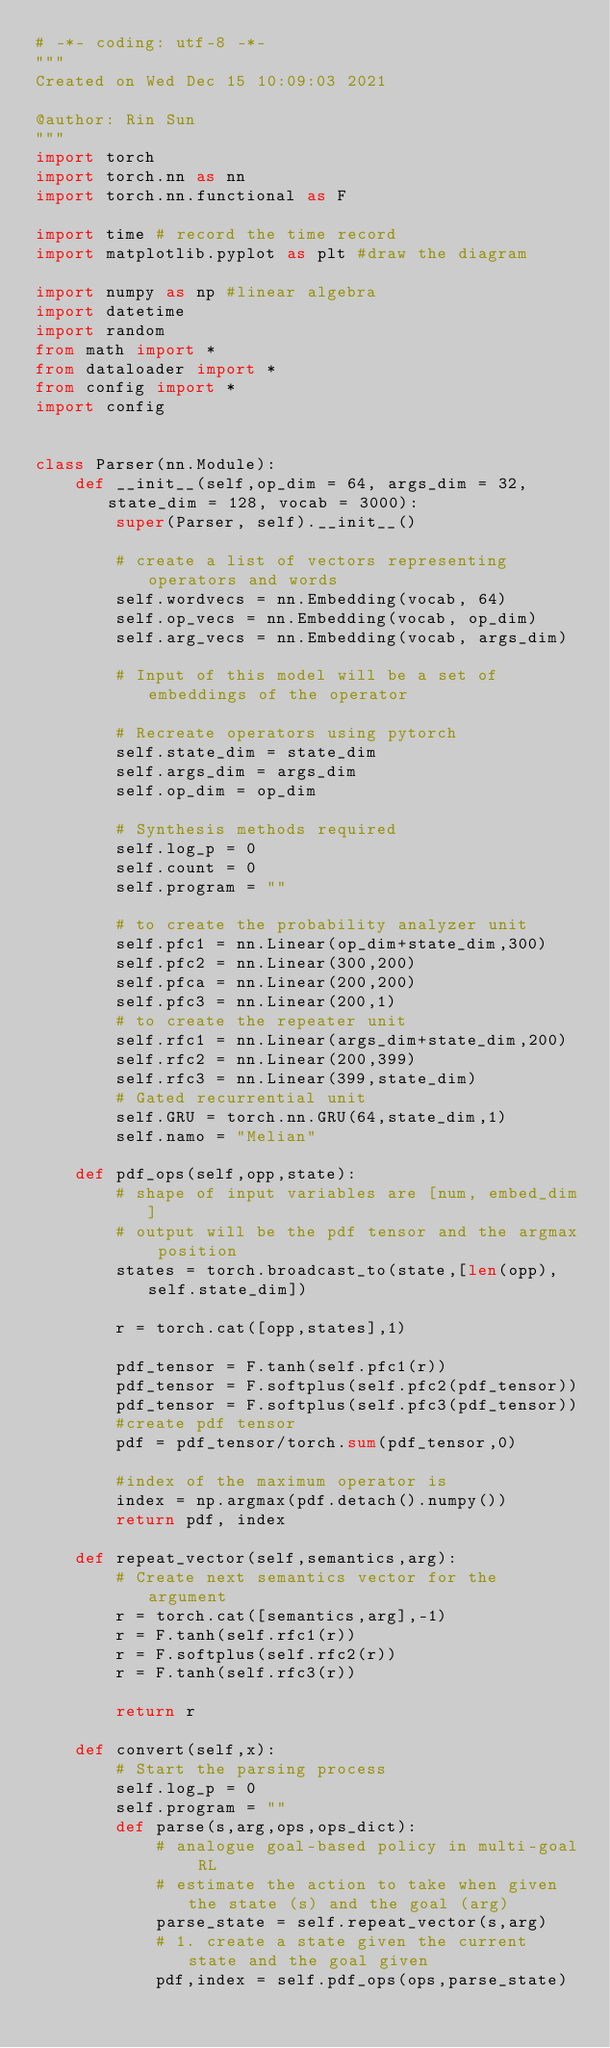Convert code to text. <code><loc_0><loc_0><loc_500><loc_500><_Python_># -*- coding: utf-8 -*-
"""
Created on Wed Dec 15 10:09:03 2021

@author: Rin Sun
"""
import torch
import torch.nn as nn
import torch.nn.functional as F

import time # record the time record
import matplotlib.pyplot as plt #draw the diagram

import numpy as np #linear algebra
import datetime
import random
from math import *
from dataloader import *
from config import *
import config


class Parser(nn.Module):
    def __init__(self,op_dim = 64, args_dim = 32,state_dim = 128, vocab = 3000):
        super(Parser, self).__init__()
        
        # create a list of vectors representing operators and words
        self.wordvecs = nn.Embedding(vocab, 64)
        self.op_vecs = nn.Embedding(vocab, op_dim)
        self.arg_vecs = nn.Embedding(vocab, args_dim)

        # Input of this model will be a set of embeddings of the operator
        
        # Recreate operators using pytorch
        self.state_dim = state_dim
        self.args_dim = args_dim
        self.op_dim = op_dim
        
        # Synthesis methods required
        self.log_p = 0
        self.count = 0
        self.program = ""
        
        # to create the probability analyzer unit
        self.pfc1 = nn.Linear(op_dim+state_dim,300)
        self.pfc2 = nn.Linear(300,200)
        self.pfca = nn.Linear(200,200)
        self.pfc3 = nn.Linear(200,1)
        # to create the repeater unit
        self.rfc1 = nn.Linear(args_dim+state_dim,200)
        self.rfc2 = nn.Linear(200,399)
        self.rfc3 = nn.Linear(399,state_dim)
        # Gated recurrential unit
        self.GRU = torch.nn.GRU(64,state_dim,1)
        self.namo = "Melian"
    
    def pdf_ops(self,opp,state):
        # shape of input variables are [num, embed_dim]
        # output will be the pdf tensor and the argmax position
        states = torch.broadcast_to(state,[len(opp),self.state_dim])

        r = torch.cat([opp,states],1)

        pdf_tensor = F.tanh(self.pfc1(r))
        pdf_tensor = F.softplus(self.pfc2(pdf_tensor))
        pdf_tensor = F.softplus(self.pfc3(pdf_tensor))
        #create pdf tensor
        pdf = pdf_tensor/torch.sum(pdf_tensor,0)
        
        #index of the maximum operator is
        index = np.argmax(pdf.detach().numpy())
        return pdf, index
    
    def repeat_vector(self,semantics,arg):
        # Create next semantics vector for the argument
        r = torch.cat([semantics,arg],-1)
        r = F.tanh(self.rfc1(r))
        r = F.softplus(self.rfc2(r))
        r = F.tanh(self.rfc3(r))
        
        return r
    
    def convert(self,x):
        # Start the parsing process
        self.log_p = 0
        self.program = ""
        def parse(s,arg,ops,ops_dict):
            # analogue goal-based policy in multi-goal RL
            # estimate the action to take when given the state (s) and the goal (arg)
            parse_state = self.repeat_vector(s,arg)
            # 1. create a state given the current state and the goal given
            pdf,index = self.pdf_ops(ops,parse_state)</code> 